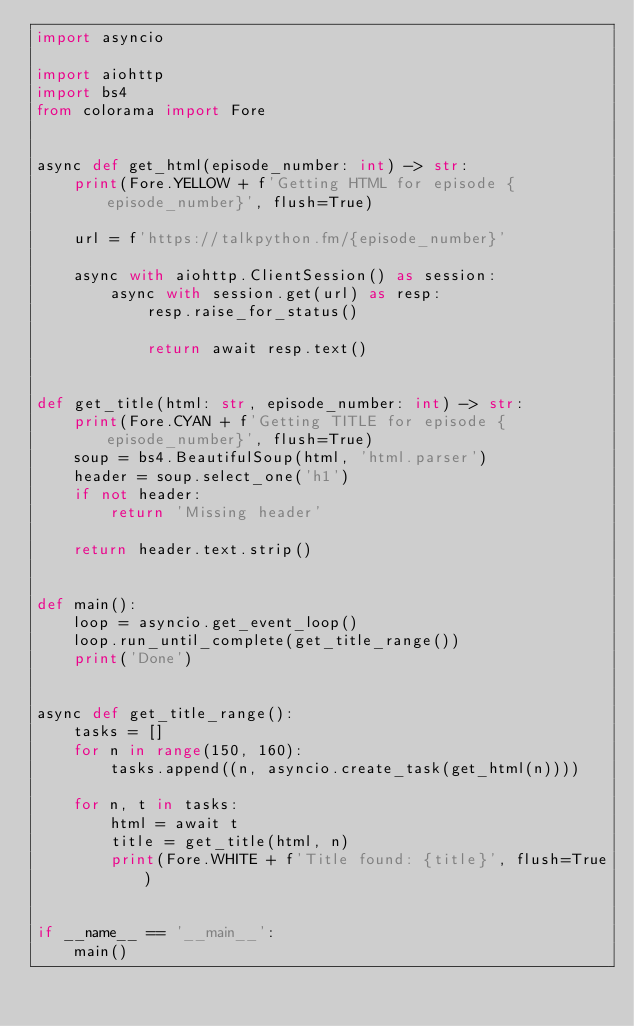<code> <loc_0><loc_0><loc_500><loc_500><_Python_>import asyncio

import aiohttp
import bs4
from colorama import Fore


async def get_html(episode_number: int) -> str:
    print(Fore.YELLOW + f'Getting HTML for episode {episode_number}', flush=True)

    url = f'https://talkpython.fm/{episode_number}'

    async with aiohttp.ClientSession() as session:
        async with session.get(url) as resp:
            resp.raise_for_status()

            return await resp.text()


def get_title(html: str, episode_number: int) -> str:
    print(Fore.CYAN + f'Getting TITLE for episode {episode_number}', flush=True)
    soup = bs4.BeautifulSoup(html, 'html.parser')
    header = soup.select_one('h1')
    if not header:
        return 'Missing header'

    return header.text.strip()


def main():
    loop = asyncio.get_event_loop()
    loop.run_until_complete(get_title_range())
    print('Done')


async def get_title_range():
    tasks = []
    for n in range(150, 160):
        tasks.append((n, asyncio.create_task(get_html(n))))

    for n, t in tasks:
        html = await t
        title = get_title(html, n)
        print(Fore.WHITE + f'Title found: {title}', flush=True)


if __name__ == '__main__':
    main()
</code> 